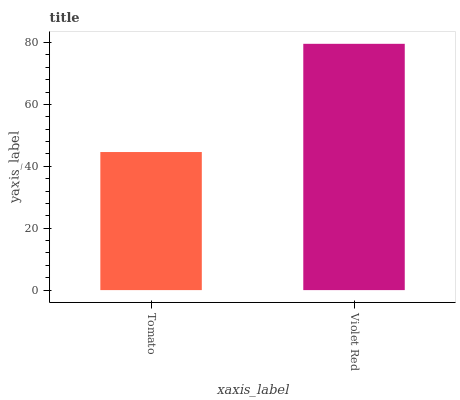Is Tomato the minimum?
Answer yes or no. Yes. Is Violet Red the maximum?
Answer yes or no. Yes. Is Violet Red the minimum?
Answer yes or no. No. Is Violet Red greater than Tomato?
Answer yes or no. Yes. Is Tomato less than Violet Red?
Answer yes or no. Yes. Is Tomato greater than Violet Red?
Answer yes or no. No. Is Violet Red less than Tomato?
Answer yes or no. No. Is Violet Red the high median?
Answer yes or no. Yes. Is Tomato the low median?
Answer yes or no. Yes. Is Tomato the high median?
Answer yes or no. No. Is Violet Red the low median?
Answer yes or no. No. 